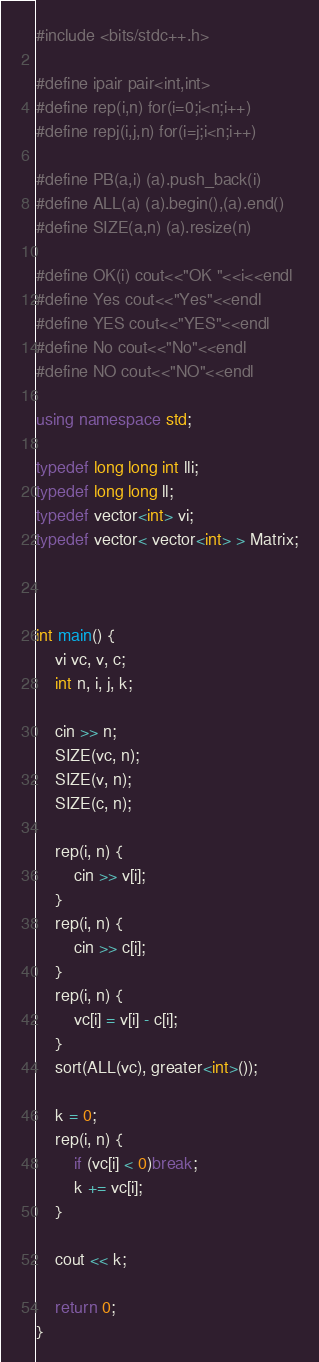<code> <loc_0><loc_0><loc_500><loc_500><_C++_>#include <bits/stdc++.h>

#define ipair pair<int,int>
#define rep(i,n) for(i=0;i<n;i++)
#define repj(i,j,n) for(i=j;i<n;i++)

#define PB(a,i) (a).push_back(i)
#define ALL(a) (a).begin(),(a).end()
#define SIZE(a,n) (a).resize(n)

#define OK(i) cout<<"OK "<<i<<endl
#define Yes cout<<"Yes"<<endl
#define YES cout<<"YES"<<endl
#define No cout<<"No"<<endl
#define NO cout<<"NO"<<endl

using namespace std;

typedef long long int lli;
typedef long long ll;
typedef vector<int> vi;
typedef vector< vector<int> > Matrix;



int main() {
	vi vc, v, c;
	int n, i, j, k;

	cin >> n;
	SIZE(vc, n);
	SIZE(v, n);
	SIZE(c, n);

	rep(i, n) {
		cin >> v[i];
	}
	rep(i, n) {
		cin >> c[i];
	}
	rep(i, n) {
		vc[i] = v[i] - c[i];
	}
	sort(ALL(vc), greater<int>());

	k = 0;
	rep(i, n) {
		if (vc[i] < 0)break;
		k += vc[i];
	}

	cout << k;

	return 0;
}
</code> 